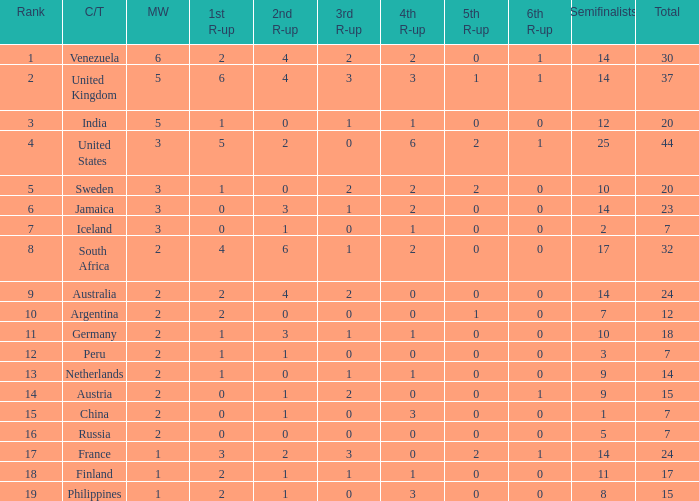What is the United States rank? 1.0. 